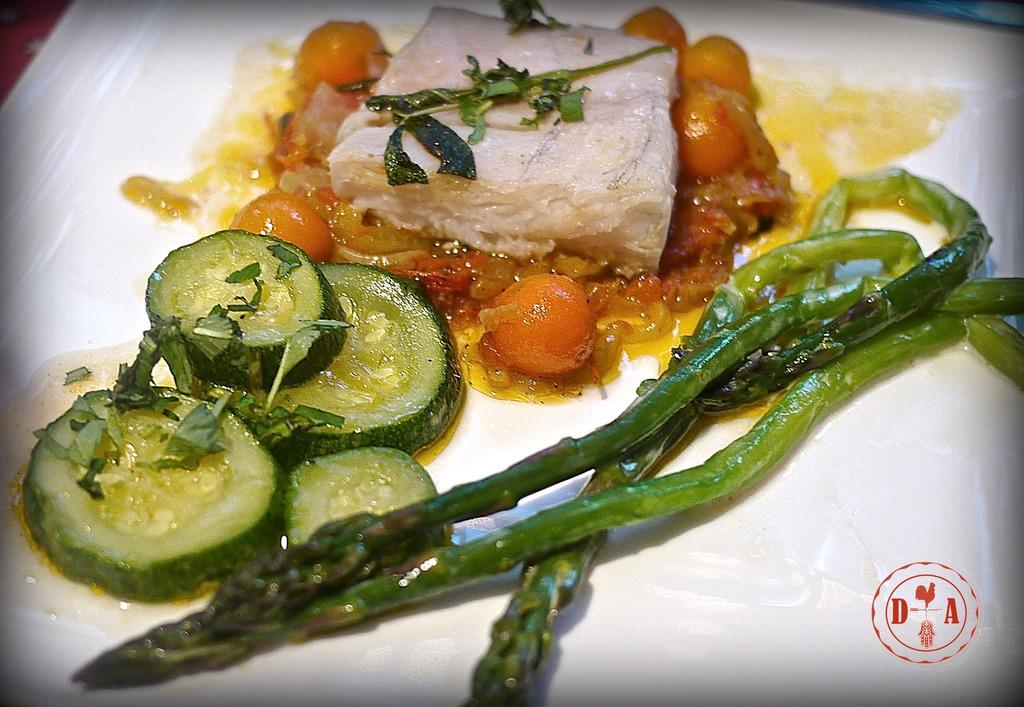What is located in the foreground of the image? There is a plate in the foreground of the image. What is on the plate? There are food items on the plate, including salad. What type of needle is used to sew the quilt in the image? There is no needle or quilt present in the image; it features a plate with food items, including salad. 